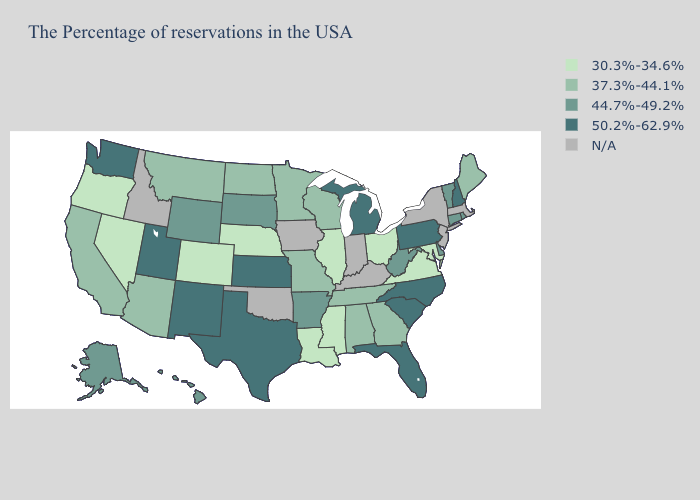Which states have the lowest value in the MidWest?
Concise answer only. Ohio, Illinois, Nebraska. What is the highest value in states that border Maryland?
Concise answer only. 50.2%-62.9%. Which states have the lowest value in the USA?
Keep it brief. Maryland, Virginia, Ohio, Illinois, Mississippi, Louisiana, Nebraska, Colorado, Nevada, Oregon. Does Utah have the lowest value in the USA?
Keep it brief. No. What is the value of Tennessee?
Concise answer only. 37.3%-44.1%. Does the map have missing data?
Short answer required. Yes. Among the states that border New Hampshire , does Vermont have the highest value?
Answer briefly. Yes. Does the first symbol in the legend represent the smallest category?
Write a very short answer. Yes. Does the map have missing data?
Be succinct. Yes. Name the states that have a value in the range N/A?
Give a very brief answer. Massachusetts, New York, New Jersey, Kentucky, Indiana, Iowa, Oklahoma, Idaho. Name the states that have a value in the range 50.2%-62.9%?
Keep it brief. New Hampshire, Pennsylvania, North Carolina, South Carolina, Florida, Michigan, Kansas, Texas, New Mexico, Utah, Washington. Among the states that border Iowa , which have the highest value?
Quick response, please. South Dakota. Among the states that border Iowa , does South Dakota have the highest value?
Quick response, please. Yes. What is the highest value in states that border South Dakota?
Concise answer only. 44.7%-49.2%. Which states have the lowest value in the USA?
Quick response, please. Maryland, Virginia, Ohio, Illinois, Mississippi, Louisiana, Nebraska, Colorado, Nevada, Oregon. 